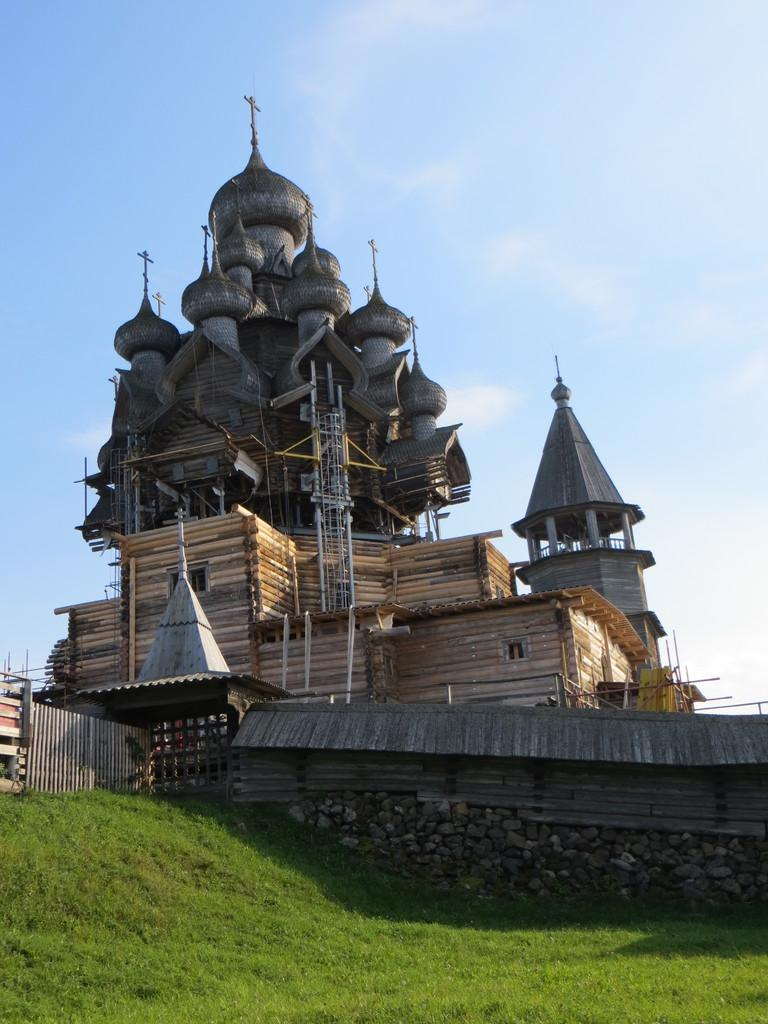What type of structures can be seen in the image? There are buildings and wooden houses in the image. What type of vegetation is visible in the image? There is grass visible in the image. What is the ground made of in the image? The ground is visible in the image, and it appears to be covered with stones. What part of the natural environment is visible in the image? The sky is visible in the image. What type of barrier can be seen in the image? There is a fence in the image. What type of toy can be seen playing with the fence in the image? There is no toy present in the image, and therefore no such activity can be observed. What is the fifth element visible in the image? The provided facts do not mention a fifth element; there are only seven elements mentioned. 